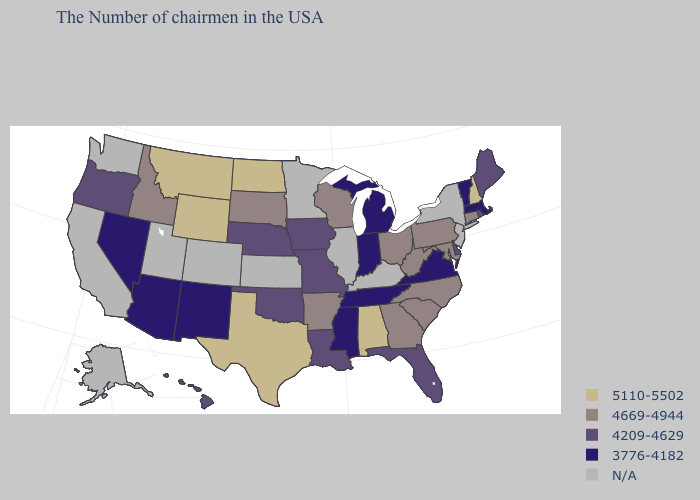What is the value of Nebraska?
Quick response, please. 4209-4629. Among the states that border Mississippi , which have the lowest value?
Give a very brief answer. Tennessee. Name the states that have a value in the range 4669-4944?
Be succinct. Connecticut, Maryland, Pennsylvania, North Carolina, South Carolina, West Virginia, Ohio, Georgia, Wisconsin, Arkansas, South Dakota, Idaho. What is the value of New York?
Short answer required. N/A. Which states have the highest value in the USA?
Quick response, please. New Hampshire, Alabama, Texas, North Dakota, Wyoming, Montana. Among the states that border California , which have the highest value?
Write a very short answer. Oregon. Which states hav the highest value in the South?
Write a very short answer. Alabama, Texas. Name the states that have a value in the range 4669-4944?
Be succinct. Connecticut, Maryland, Pennsylvania, North Carolina, South Carolina, West Virginia, Ohio, Georgia, Wisconsin, Arkansas, South Dakota, Idaho. Name the states that have a value in the range N/A?
Be succinct. New York, New Jersey, Kentucky, Illinois, Minnesota, Kansas, Colorado, Utah, California, Washington, Alaska. Name the states that have a value in the range 4669-4944?
Concise answer only. Connecticut, Maryland, Pennsylvania, North Carolina, South Carolina, West Virginia, Ohio, Georgia, Wisconsin, Arkansas, South Dakota, Idaho. Name the states that have a value in the range 4209-4629?
Give a very brief answer. Maine, Rhode Island, Delaware, Florida, Louisiana, Missouri, Iowa, Nebraska, Oklahoma, Oregon, Hawaii. Name the states that have a value in the range N/A?
Short answer required. New York, New Jersey, Kentucky, Illinois, Minnesota, Kansas, Colorado, Utah, California, Washington, Alaska. Name the states that have a value in the range 4209-4629?
Be succinct. Maine, Rhode Island, Delaware, Florida, Louisiana, Missouri, Iowa, Nebraska, Oklahoma, Oregon, Hawaii. Among the states that border Wyoming , does Nebraska have the lowest value?
Quick response, please. Yes. 